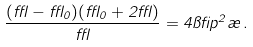<formula> <loc_0><loc_0><loc_500><loc_500>\frac { ( \epsilon - \epsilon _ { 0 } ) ( \epsilon _ { 0 } + 2 \epsilon ) } { \epsilon } = 4 \pi \beta p ^ { 2 } \rho \, .</formula> 